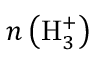<formula> <loc_0><loc_0><loc_500><loc_500>n \left ( H _ { 3 } ^ { + } \right )</formula> 